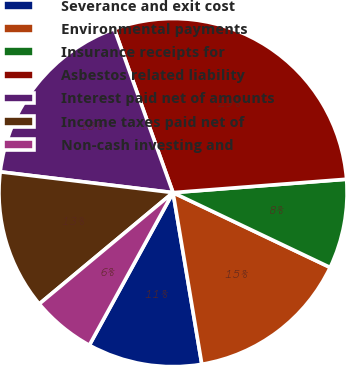<chart> <loc_0><loc_0><loc_500><loc_500><pie_chart><fcel>Severance and exit cost<fcel>Environmental payments<fcel>Insurance receipts for<fcel>Asbestos related liability<fcel>Interest paid net of amounts<fcel>Income taxes paid net of<fcel>Non-cash investing and<nl><fcel>10.63%<fcel>15.28%<fcel>8.3%<fcel>29.26%<fcel>17.61%<fcel>12.95%<fcel>5.97%<nl></chart> 